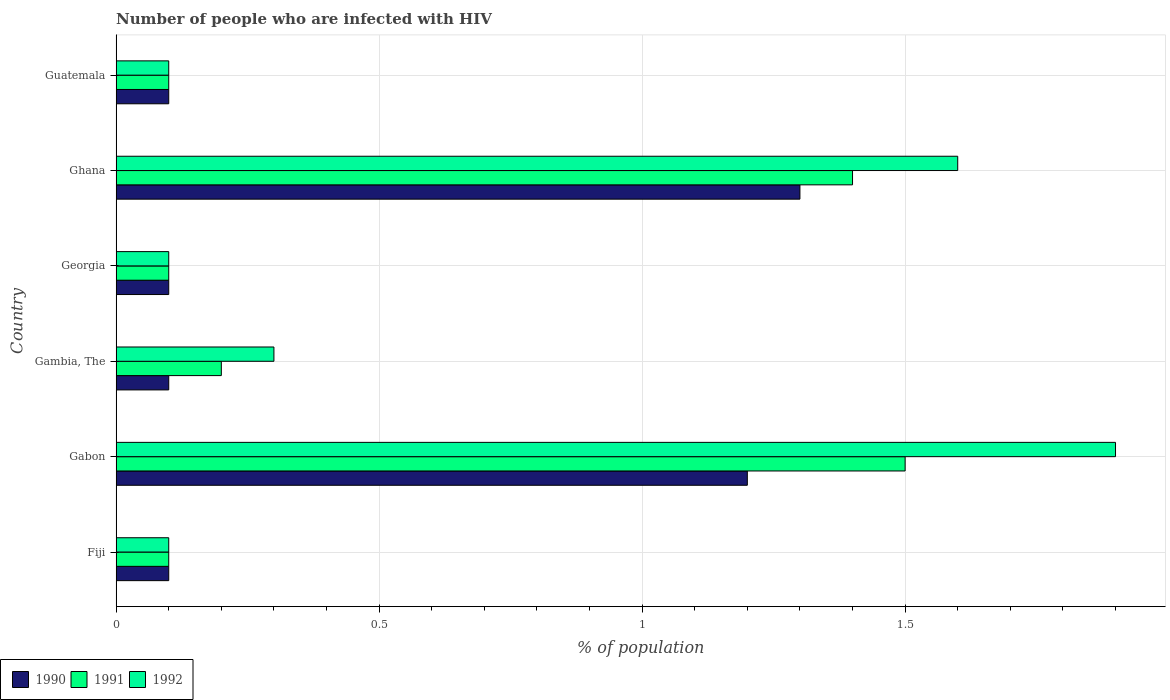What is the label of the 3rd group of bars from the top?
Your answer should be very brief. Georgia. In how many cases, is the number of bars for a given country not equal to the number of legend labels?
Your answer should be very brief. 0. What is the percentage of HIV infected population in in 1992 in Ghana?
Your answer should be compact. 1.6. Across all countries, what is the minimum percentage of HIV infected population in in 1991?
Ensure brevity in your answer.  0.1. In which country was the percentage of HIV infected population in in 1991 maximum?
Provide a short and direct response. Gabon. In which country was the percentage of HIV infected population in in 1992 minimum?
Ensure brevity in your answer.  Fiji. What is the difference between the percentage of HIV infected population in in 1992 in Gambia, The and that in Ghana?
Offer a very short reply. -1.3. What is the average percentage of HIV infected population in in 1991 per country?
Provide a short and direct response. 0.57. What is the difference between the percentage of HIV infected population in in 1990 and percentage of HIV infected population in in 1991 in Fiji?
Give a very brief answer. 0. What is the ratio of the percentage of HIV infected population in in 1991 in Gabon to that in Georgia?
Offer a very short reply. 15. Is the percentage of HIV infected population in in 1992 in Fiji less than that in Gabon?
Offer a very short reply. Yes. Is the difference between the percentage of HIV infected population in in 1990 in Ghana and Guatemala greater than the difference between the percentage of HIV infected population in in 1991 in Ghana and Guatemala?
Provide a short and direct response. No. What is the difference between the highest and the second highest percentage of HIV infected population in in 1991?
Keep it short and to the point. 0.1. In how many countries, is the percentage of HIV infected population in in 1991 greater than the average percentage of HIV infected population in in 1991 taken over all countries?
Offer a terse response. 2. Is the sum of the percentage of HIV infected population in in 1990 in Georgia and Ghana greater than the maximum percentage of HIV infected population in in 1991 across all countries?
Your response must be concise. No. What does the 2nd bar from the top in Gambia, The represents?
Provide a short and direct response. 1991. What does the 3rd bar from the bottom in Ghana represents?
Make the answer very short. 1992. Is it the case that in every country, the sum of the percentage of HIV infected population in in 1991 and percentage of HIV infected population in in 1990 is greater than the percentage of HIV infected population in in 1992?
Offer a terse response. Yes. How many countries are there in the graph?
Your response must be concise. 6. What is the difference between two consecutive major ticks on the X-axis?
Your answer should be very brief. 0.5. Are the values on the major ticks of X-axis written in scientific E-notation?
Ensure brevity in your answer.  No. Does the graph contain any zero values?
Ensure brevity in your answer.  No. Does the graph contain grids?
Offer a very short reply. Yes. Where does the legend appear in the graph?
Provide a succinct answer. Bottom left. How many legend labels are there?
Provide a short and direct response. 3. What is the title of the graph?
Ensure brevity in your answer.  Number of people who are infected with HIV. What is the label or title of the X-axis?
Keep it short and to the point. % of population. What is the % of population of 1990 in Fiji?
Keep it short and to the point. 0.1. What is the % of population in 1992 in Fiji?
Offer a very short reply. 0.1. What is the % of population of 1991 in Gambia, The?
Give a very brief answer. 0.2. What is the % of population in 1992 in Gambia, The?
Ensure brevity in your answer.  0.3. What is the % of population of 1990 in Ghana?
Provide a succinct answer. 1.3. What is the % of population in 1990 in Guatemala?
Offer a very short reply. 0.1. Across all countries, what is the maximum % of population in 1990?
Your answer should be very brief. 1.3. Across all countries, what is the minimum % of population in 1990?
Your answer should be compact. 0.1. Across all countries, what is the minimum % of population of 1991?
Your response must be concise. 0.1. What is the total % of population in 1990 in the graph?
Your answer should be very brief. 2.9. What is the total % of population of 1992 in the graph?
Keep it short and to the point. 4.1. What is the difference between the % of population of 1991 in Fiji and that in Gabon?
Give a very brief answer. -1.4. What is the difference between the % of population in 1992 in Fiji and that in Gabon?
Make the answer very short. -1.8. What is the difference between the % of population of 1990 in Fiji and that in Gambia, The?
Your response must be concise. 0. What is the difference between the % of population of 1991 in Fiji and that in Gambia, The?
Make the answer very short. -0.1. What is the difference between the % of population of 1990 in Fiji and that in Georgia?
Make the answer very short. 0. What is the difference between the % of population of 1990 in Fiji and that in Ghana?
Provide a short and direct response. -1.2. What is the difference between the % of population of 1991 in Fiji and that in Ghana?
Provide a succinct answer. -1.3. What is the difference between the % of population in 1992 in Fiji and that in Ghana?
Provide a succinct answer. -1.5. What is the difference between the % of population in 1992 in Fiji and that in Guatemala?
Ensure brevity in your answer.  0. What is the difference between the % of population in 1990 in Gabon and that in Gambia, The?
Your answer should be compact. 1.1. What is the difference between the % of population of 1992 in Gabon and that in Gambia, The?
Your answer should be very brief. 1.6. What is the difference between the % of population in 1991 in Gabon and that in Ghana?
Offer a terse response. 0.1. What is the difference between the % of population of 1992 in Gabon and that in Ghana?
Your answer should be very brief. 0.3. What is the difference between the % of population of 1991 in Gambia, The and that in Georgia?
Offer a terse response. 0.1. What is the difference between the % of population of 1992 in Gambia, The and that in Georgia?
Your answer should be compact. 0.2. What is the difference between the % of population in 1990 in Gambia, The and that in Ghana?
Ensure brevity in your answer.  -1.2. What is the difference between the % of population of 1992 in Gambia, The and that in Ghana?
Offer a very short reply. -1.3. What is the difference between the % of population in 1990 in Gambia, The and that in Guatemala?
Your answer should be very brief. 0. What is the difference between the % of population of 1991 in Gambia, The and that in Guatemala?
Your response must be concise. 0.1. What is the difference between the % of population in 1992 in Gambia, The and that in Guatemala?
Ensure brevity in your answer.  0.2. What is the difference between the % of population of 1990 in Georgia and that in Ghana?
Ensure brevity in your answer.  -1.2. What is the difference between the % of population of 1992 in Georgia and that in Ghana?
Your answer should be very brief. -1.5. What is the difference between the % of population of 1991 in Georgia and that in Guatemala?
Make the answer very short. 0. What is the difference between the % of population in 1990 in Ghana and that in Guatemala?
Provide a succinct answer. 1.2. What is the difference between the % of population of 1992 in Ghana and that in Guatemala?
Provide a succinct answer. 1.5. What is the difference between the % of population of 1990 in Fiji and the % of population of 1992 in Gabon?
Ensure brevity in your answer.  -1.8. What is the difference between the % of population in 1990 in Fiji and the % of population in 1991 in Gambia, The?
Your response must be concise. -0.1. What is the difference between the % of population in 1991 in Fiji and the % of population in 1992 in Gambia, The?
Your answer should be very brief. -0.2. What is the difference between the % of population of 1990 in Fiji and the % of population of 1991 in Georgia?
Your response must be concise. 0. What is the difference between the % of population of 1990 in Fiji and the % of population of 1991 in Ghana?
Ensure brevity in your answer.  -1.3. What is the difference between the % of population of 1990 in Fiji and the % of population of 1992 in Ghana?
Make the answer very short. -1.5. What is the difference between the % of population in 1991 in Fiji and the % of population in 1992 in Ghana?
Your answer should be very brief. -1.5. What is the difference between the % of population of 1990 in Fiji and the % of population of 1992 in Guatemala?
Ensure brevity in your answer.  0. What is the difference between the % of population of 1991 in Fiji and the % of population of 1992 in Guatemala?
Ensure brevity in your answer.  0. What is the difference between the % of population in 1990 in Gabon and the % of population in 1991 in Gambia, The?
Your answer should be very brief. 1. What is the difference between the % of population in 1990 in Gabon and the % of population in 1992 in Georgia?
Ensure brevity in your answer.  1.1. What is the difference between the % of population in 1991 in Gabon and the % of population in 1992 in Georgia?
Keep it short and to the point. 1.4. What is the difference between the % of population in 1991 in Gabon and the % of population in 1992 in Ghana?
Your answer should be very brief. -0.1. What is the difference between the % of population in 1991 in Gabon and the % of population in 1992 in Guatemala?
Give a very brief answer. 1.4. What is the difference between the % of population in 1990 in Gambia, The and the % of population in 1992 in Georgia?
Your response must be concise. 0. What is the difference between the % of population of 1991 in Gambia, The and the % of population of 1992 in Georgia?
Give a very brief answer. 0.1. What is the difference between the % of population of 1990 in Gambia, The and the % of population of 1991 in Ghana?
Offer a terse response. -1.3. What is the difference between the % of population of 1990 in Gambia, The and the % of population of 1992 in Ghana?
Give a very brief answer. -1.5. What is the difference between the % of population of 1990 in Georgia and the % of population of 1991 in Ghana?
Offer a terse response. -1.3. What is the difference between the % of population of 1990 in Georgia and the % of population of 1992 in Ghana?
Your response must be concise. -1.5. What is the difference between the % of population in 1991 in Georgia and the % of population in 1992 in Ghana?
Your answer should be very brief. -1.5. What is the difference between the % of population of 1990 in Georgia and the % of population of 1991 in Guatemala?
Your response must be concise. 0. What is the difference between the % of population of 1990 in Georgia and the % of population of 1992 in Guatemala?
Make the answer very short. 0. What is the difference between the % of population in 1990 in Ghana and the % of population in 1991 in Guatemala?
Provide a short and direct response. 1.2. What is the difference between the % of population of 1990 in Ghana and the % of population of 1992 in Guatemala?
Make the answer very short. 1.2. What is the difference between the % of population of 1991 in Ghana and the % of population of 1992 in Guatemala?
Offer a very short reply. 1.3. What is the average % of population in 1990 per country?
Offer a terse response. 0.48. What is the average % of population in 1991 per country?
Offer a very short reply. 0.57. What is the average % of population of 1992 per country?
Keep it short and to the point. 0.68. What is the difference between the % of population of 1990 and % of population of 1991 in Fiji?
Provide a succinct answer. 0. What is the difference between the % of population of 1990 and % of population of 1992 in Fiji?
Provide a short and direct response. 0. What is the difference between the % of population of 1990 and % of population of 1991 in Gabon?
Offer a very short reply. -0.3. What is the difference between the % of population of 1991 and % of population of 1992 in Gabon?
Your answer should be compact. -0.4. What is the difference between the % of population of 1991 and % of population of 1992 in Gambia, The?
Offer a terse response. -0.1. What is the difference between the % of population in 1990 and % of population in 1992 in Georgia?
Keep it short and to the point. 0. What is the difference between the % of population of 1991 and % of population of 1992 in Georgia?
Your response must be concise. 0. What is the difference between the % of population of 1990 and % of population of 1992 in Ghana?
Offer a very short reply. -0.3. What is the difference between the % of population of 1990 and % of population of 1991 in Guatemala?
Give a very brief answer. 0. What is the ratio of the % of population in 1990 in Fiji to that in Gabon?
Your response must be concise. 0.08. What is the ratio of the % of population of 1991 in Fiji to that in Gabon?
Offer a terse response. 0.07. What is the ratio of the % of population in 1992 in Fiji to that in Gabon?
Offer a terse response. 0.05. What is the ratio of the % of population in 1991 in Fiji to that in Gambia, The?
Offer a terse response. 0.5. What is the ratio of the % of population in 1992 in Fiji to that in Georgia?
Provide a short and direct response. 1. What is the ratio of the % of population of 1990 in Fiji to that in Ghana?
Offer a terse response. 0.08. What is the ratio of the % of population of 1991 in Fiji to that in Ghana?
Give a very brief answer. 0.07. What is the ratio of the % of population in 1992 in Fiji to that in Ghana?
Offer a terse response. 0.06. What is the ratio of the % of population in 1990 in Fiji to that in Guatemala?
Your response must be concise. 1. What is the ratio of the % of population of 1992 in Fiji to that in Guatemala?
Your response must be concise. 1. What is the ratio of the % of population in 1992 in Gabon to that in Gambia, The?
Provide a succinct answer. 6.33. What is the ratio of the % of population of 1990 in Gabon to that in Georgia?
Offer a very short reply. 12. What is the ratio of the % of population of 1991 in Gabon to that in Ghana?
Give a very brief answer. 1.07. What is the ratio of the % of population of 1992 in Gabon to that in Ghana?
Ensure brevity in your answer.  1.19. What is the ratio of the % of population in 1992 in Gambia, The to that in Georgia?
Keep it short and to the point. 3. What is the ratio of the % of population of 1990 in Gambia, The to that in Ghana?
Offer a terse response. 0.08. What is the ratio of the % of population in 1991 in Gambia, The to that in Ghana?
Your response must be concise. 0.14. What is the ratio of the % of population in 1992 in Gambia, The to that in Ghana?
Make the answer very short. 0.19. What is the ratio of the % of population in 1990 in Gambia, The to that in Guatemala?
Make the answer very short. 1. What is the ratio of the % of population of 1991 in Gambia, The to that in Guatemala?
Your response must be concise. 2. What is the ratio of the % of population of 1992 in Gambia, The to that in Guatemala?
Your answer should be very brief. 3. What is the ratio of the % of population of 1990 in Georgia to that in Ghana?
Provide a succinct answer. 0.08. What is the ratio of the % of population in 1991 in Georgia to that in Ghana?
Offer a very short reply. 0.07. What is the ratio of the % of population in 1992 in Georgia to that in Ghana?
Your answer should be compact. 0.06. What is the ratio of the % of population of 1990 in Georgia to that in Guatemala?
Provide a short and direct response. 1. What is the ratio of the % of population of 1991 in Georgia to that in Guatemala?
Provide a short and direct response. 1. What is the ratio of the % of population in 1990 in Ghana to that in Guatemala?
Make the answer very short. 13. What is the ratio of the % of population of 1992 in Ghana to that in Guatemala?
Your response must be concise. 16. What is the difference between the highest and the lowest % of population in 1990?
Offer a terse response. 1.2. What is the difference between the highest and the lowest % of population in 1991?
Provide a succinct answer. 1.4. 